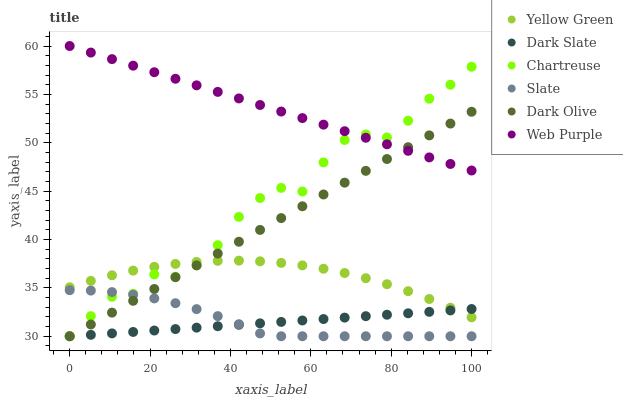Does Dark Slate have the minimum area under the curve?
Answer yes or no. Yes. Does Web Purple have the maximum area under the curve?
Answer yes or no. Yes. Does Slate have the minimum area under the curve?
Answer yes or no. No. Does Slate have the maximum area under the curve?
Answer yes or no. No. Is Dark Slate the smoothest?
Answer yes or no. Yes. Is Chartreuse the roughest?
Answer yes or no. Yes. Is Slate the smoothest?
Answer yes or no. No. Is Slate the roughest?
Answer yes or no. No. Does Slate have the lowest value?
Answer yes or no. Yes. Does Web Purple have the lowest value?
Answer yes or no. No. Does Web Purple have the highest value?
Answer yes or no. Yes. Does Slate have the highest value?
Answer yes or no. No. Is Slate less than Web Purple?
Answer yes or no. Yes. Is Yellow Green greater than Slate?
Answer yes or no. Yes. Does Slate intersect Chartreuse?
Answer yes or no. Yes. Is Slate less than Chartreuse?
Answer yes or no. No. Is Slate greater than Chartreuse?
Answer yes or no. No. Does Slate intersect Web Purple?
Answer yes or no. No. 